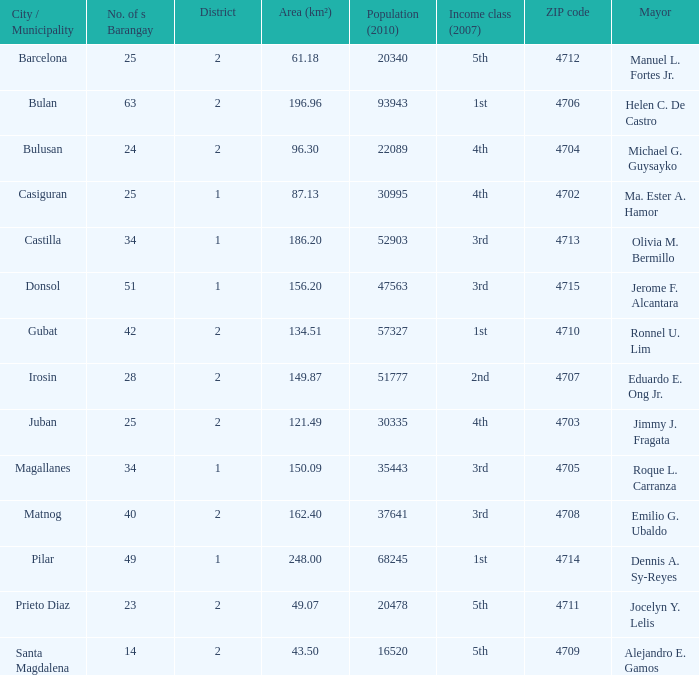For a region measuring 134.51 square kilometers, what was the population count in 2010? 1.0. 